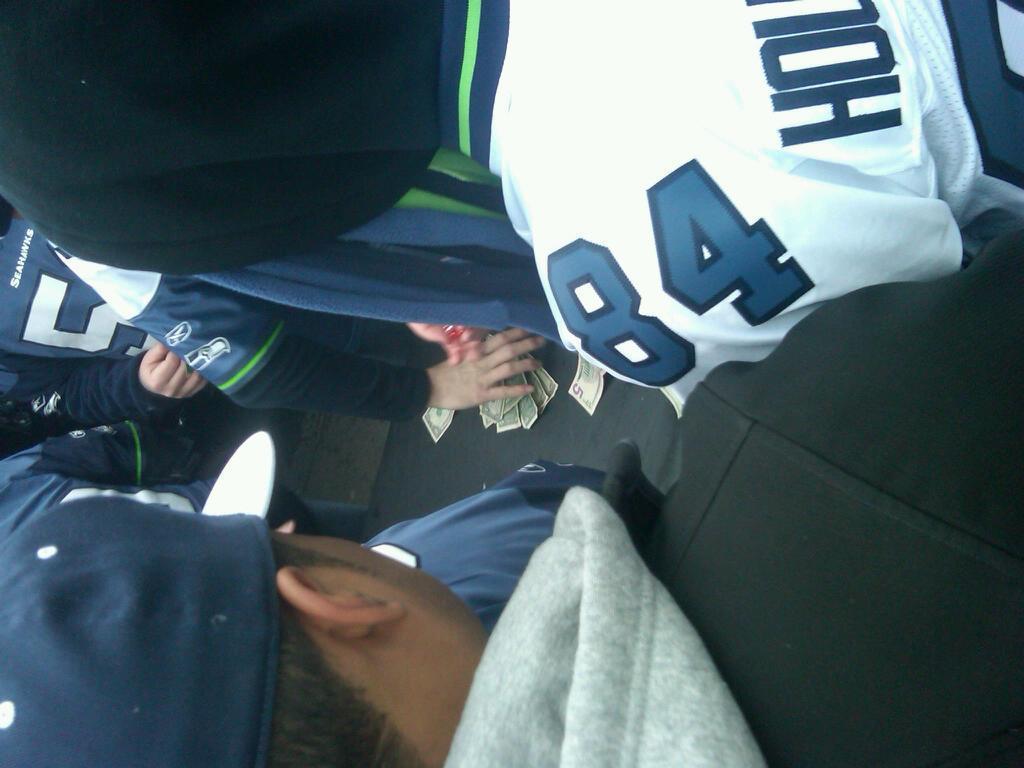In one or two sentences, can you explain what this image depicts? In this image I can see few people around and wearing blue,white,black and ash color dress. I can see a person hand and money. 